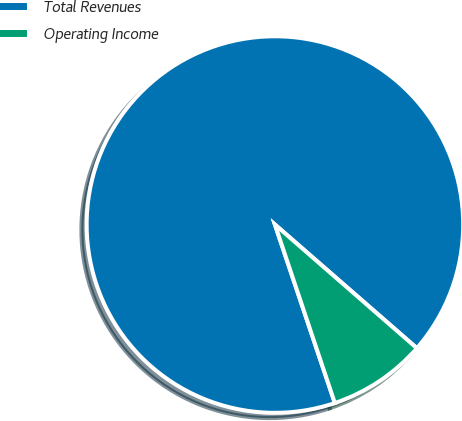<chart> <loc_0><loc_0><loc_500><loc_500><pie_chart><fcel>Total Revenues<fcel>Operating Income<nl><fcel>91.56%<fcel>8.44%<nl></chart> 